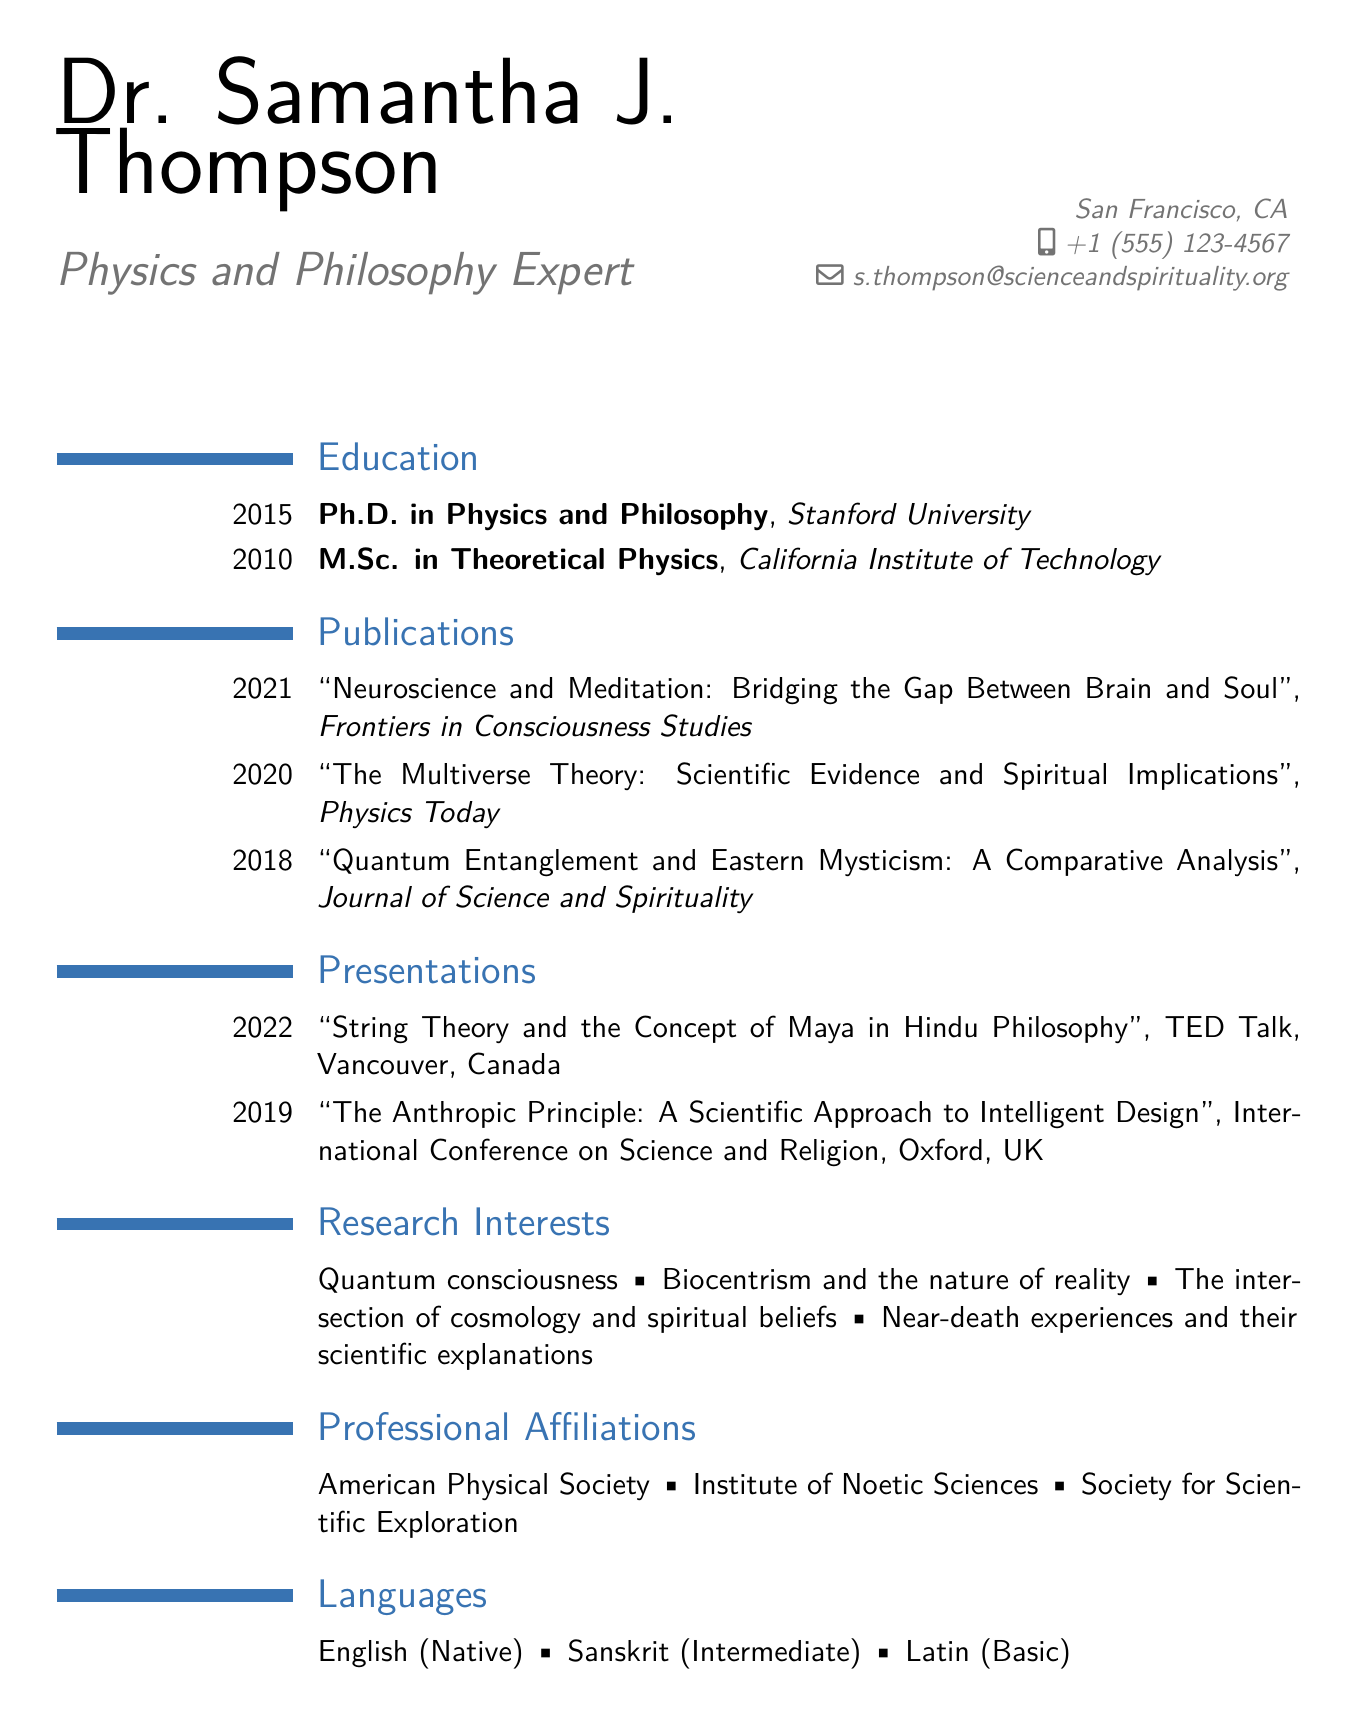what is the name of the individual? The name of the individual is listed at the top of the document under the personal information section.
Answer: Dr. Samantha J. Thompson which university did Dr. Thompson receive her Ph.D. from? The university where Dr. Thompson obtained her Ph.D. is mentioned in the education section.
Answer: Stanford University what year did Dr. Thompson publish her paper on neuroscience and meditation? The publication year of the paper on neuroscience and meditation is noted in the publications section.
Answer: 2021 how many languages does Dr. Thompson speak? The number of languages spoken by Dr. Thompson is provided in the languages section.
Answer: Three what is one of Dr. Thompson's research interests? The research interests are listed in a separate section, indicating areas of focus.
Answer: Quantum consciousness in which conference did Dr. Thompson present in 2019? The specific name of the conference where Dr. Thompson presented in 2019 is described in the presentations section.
Answer: International Conference on Science and Religion what is the title of the TED Talk given by Dr. Thompson? The title of the TED Talk is found in the presentations section of the document.
Answer: String Theory and the Concept of Maya in Hindu Philosophy what journal published Dr. Thompson's article on multiverse theory? The name of the journal that published the article on multiverse theory is reflected in the publications section.
Answer: Physics Today 